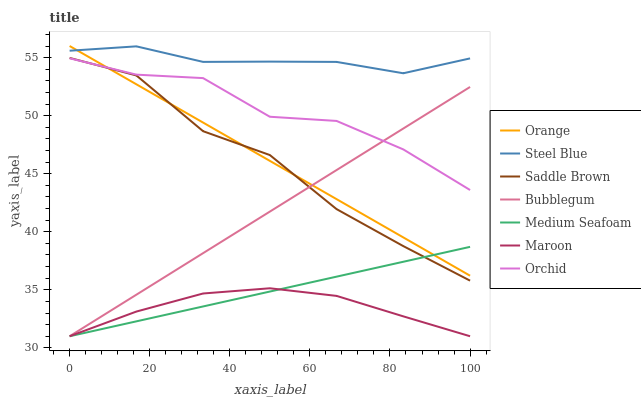Does Maroon have the minimum area under the curve?
Answer yes or no. Yes. Does Steel Blue have the maximum area under the curve?
Answer yes or no. Yes. Does Saddle Brown have the minimum area under the curve?
Answer yes or no. No. Does Saddle Brown have the maximum area under the curve?
Answer yes or no. No. Is Bubblegum the smoothest?
Answer yes or no. Yes. Is Saddle Brown the roughest?
Answer yes or no. Yes. Is Maroon the smoothest?
Answer yes or no. No. Is Maroon the roughest?
Answer yes or no. No. Does Saddle Brown have the lowest value?
Answer yes or no. No. Does Orange have the highest value?
Answer yes or no. Yes. Does Saddle Brown have the highest value?
Answer yes or no. No. Is Maroon less than Orange?
Answer yes or no. Yes. Is Steel Blue greater than Orchid?
Answer yes or no. Yes. Does Orange intersect Bubblegum?
Answer yes or no. Yes. Is Orange less than Bubblegum?
Answer yes or no. No. Is Orange greater than Bubblegum?
Answer yes or no. No. Does Maroon intersect Orange?
Answer yes or no. No. 